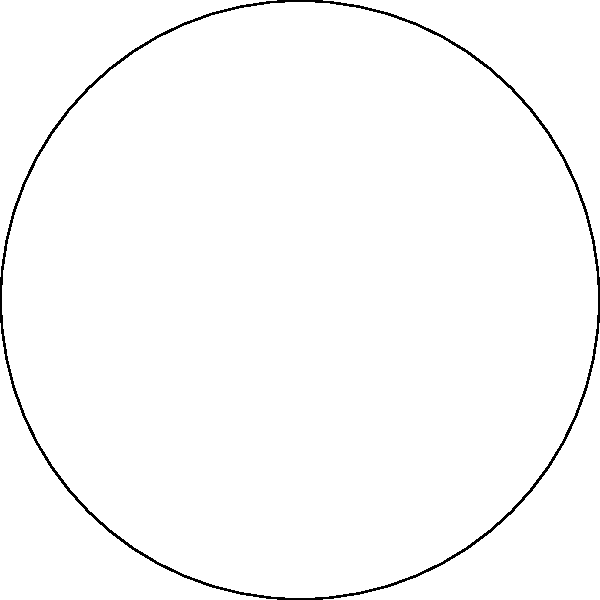As a TV show producer creating educational content, you're working on a geometry segment. You want to present a challenging problem to your audience about a regular pentagon inscribed in a circle. Given that the radius of the circle is $r$ and the side length of the pentagon is $s$, derive an expression for $s$ in terms of $r$. How would you present this problem to make it engaging for viewers while maintaining mathematical rigor? To solve this problem and present it engagingly to viewers, we can follow these steps:

1) First, we need to recognize that the pentagon is divided into 5 equal triangles, each with a central angle of $\frac{2\pi}{5} = 72°$.

2) Focus on one of these triangles, say $\triangle OA_1A_2$. This is an isosceles triangle with two sides of length $r$ and base $s$.

3) The angle at the center, $\angle A_1OA_2$, is $72°$. Therefore, the angle $\angle OA_1A_2$ is:
   
   $$\angle OA_1A_2 = \frac{180° - 72°}{2} = 54°$$

4) Now we can use the sine function to find $s$:

   $$\sin 72° = \frac{s/2}{r}$$

5) Solving for $s$:

   $$s = 2r \sin 72°$$

6) To make this more precise, we can express $\sin 72°$ in terms of radicals:

   $$\sin 72° = \frac{\sqrt{5} + 1}{4}$$

7) Therefore, our final expression is:

   $$s = r(\sqrt{5} + 1)$$

To make this engaging for viewers:
- Start with a visual representation of the problem, similar to the provided diagram.
- Gradually build up the solution, explaining each step clearly.
- Use animations to show how the central angle relates to the pentagon's symmetry.
- Highlight the isosceles triangle and how it's key to solving the problem.
- Relate this to real-world applications, such as architecture or design, where regular pentagons might be used.
Answer: $s = r(\sqrt{5} + 1)$ 